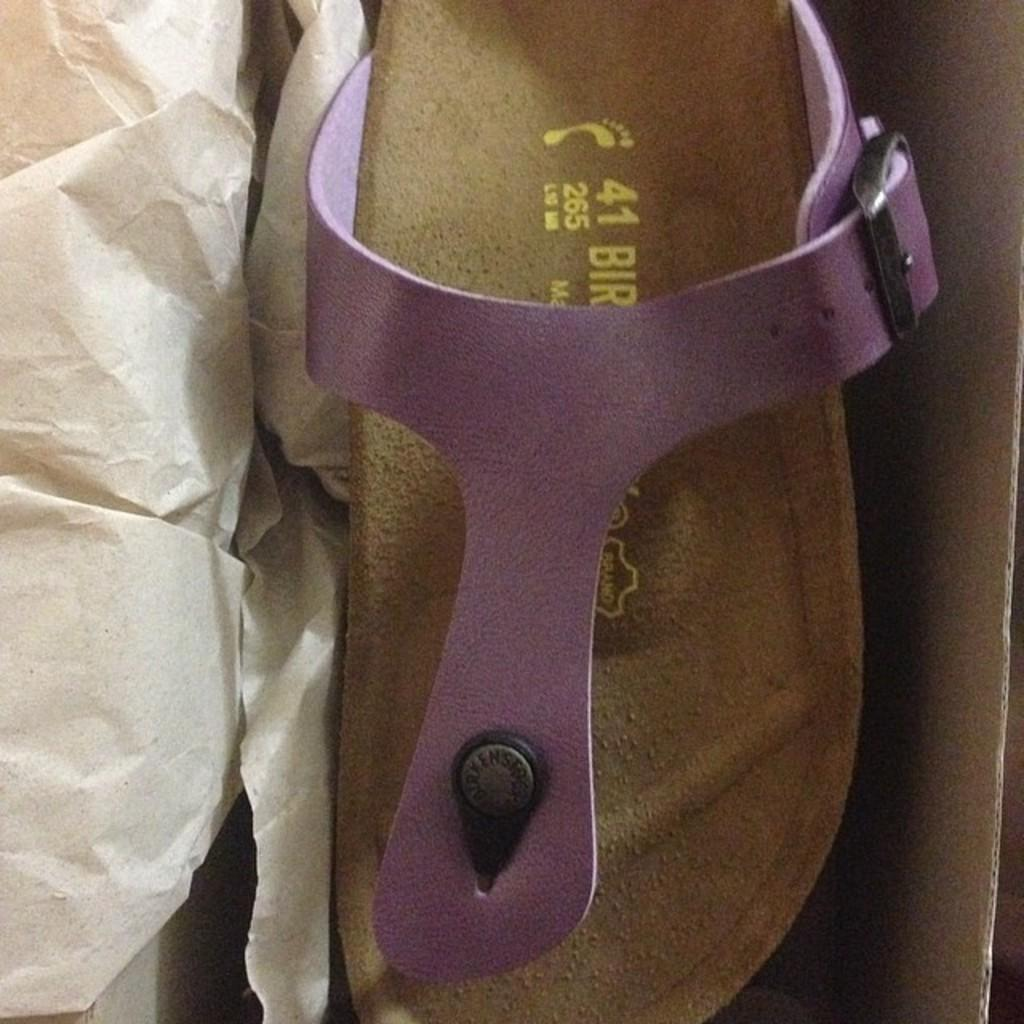What type of footwear is placed in the carton in the image? There is a chappal (sandal) placed in a carton in the image. What else can be seen in the image besides the chappal? There is a paper in the image. What industry is depicted in the image? There is no industry depicted in the image; it only shows a chappal placed in a carton and a paper. 